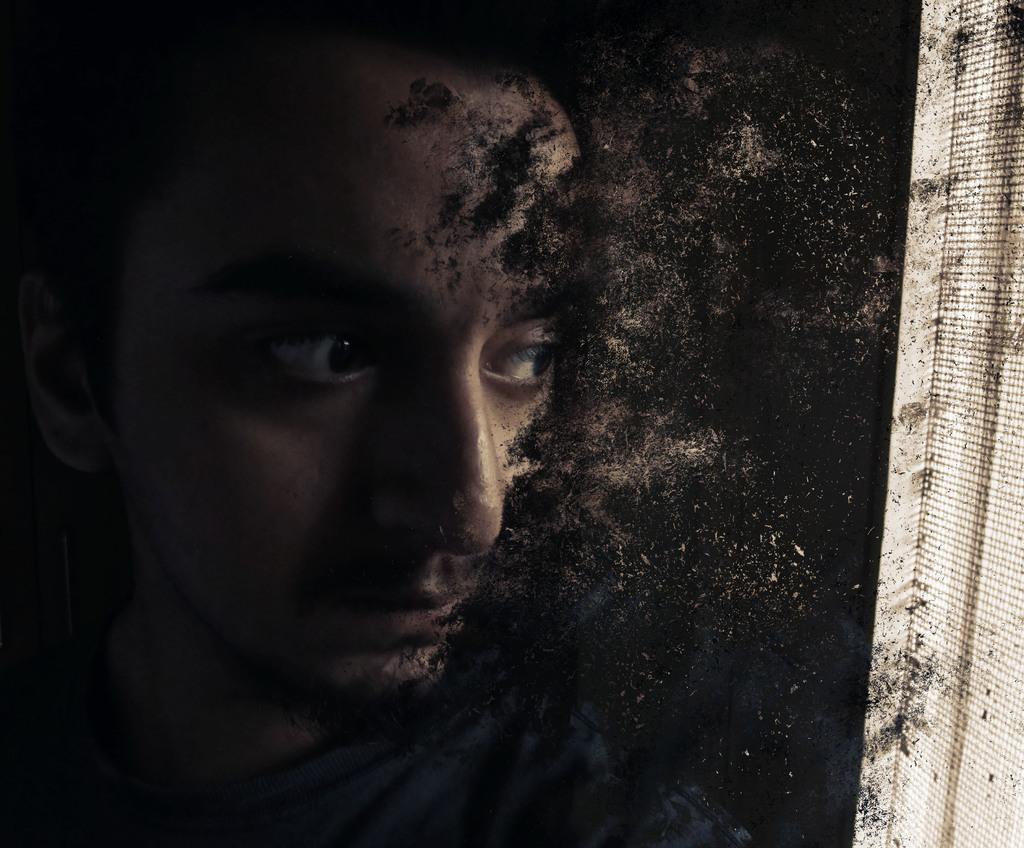What is the main subject of the image? There is a person in the image. Can you describe the person's position in relation to the wall? The person is standing near a wall. What type of throat medicine is the person holding in the image? There is no throat medicine present in the image; it only features a person standing near a wall. 